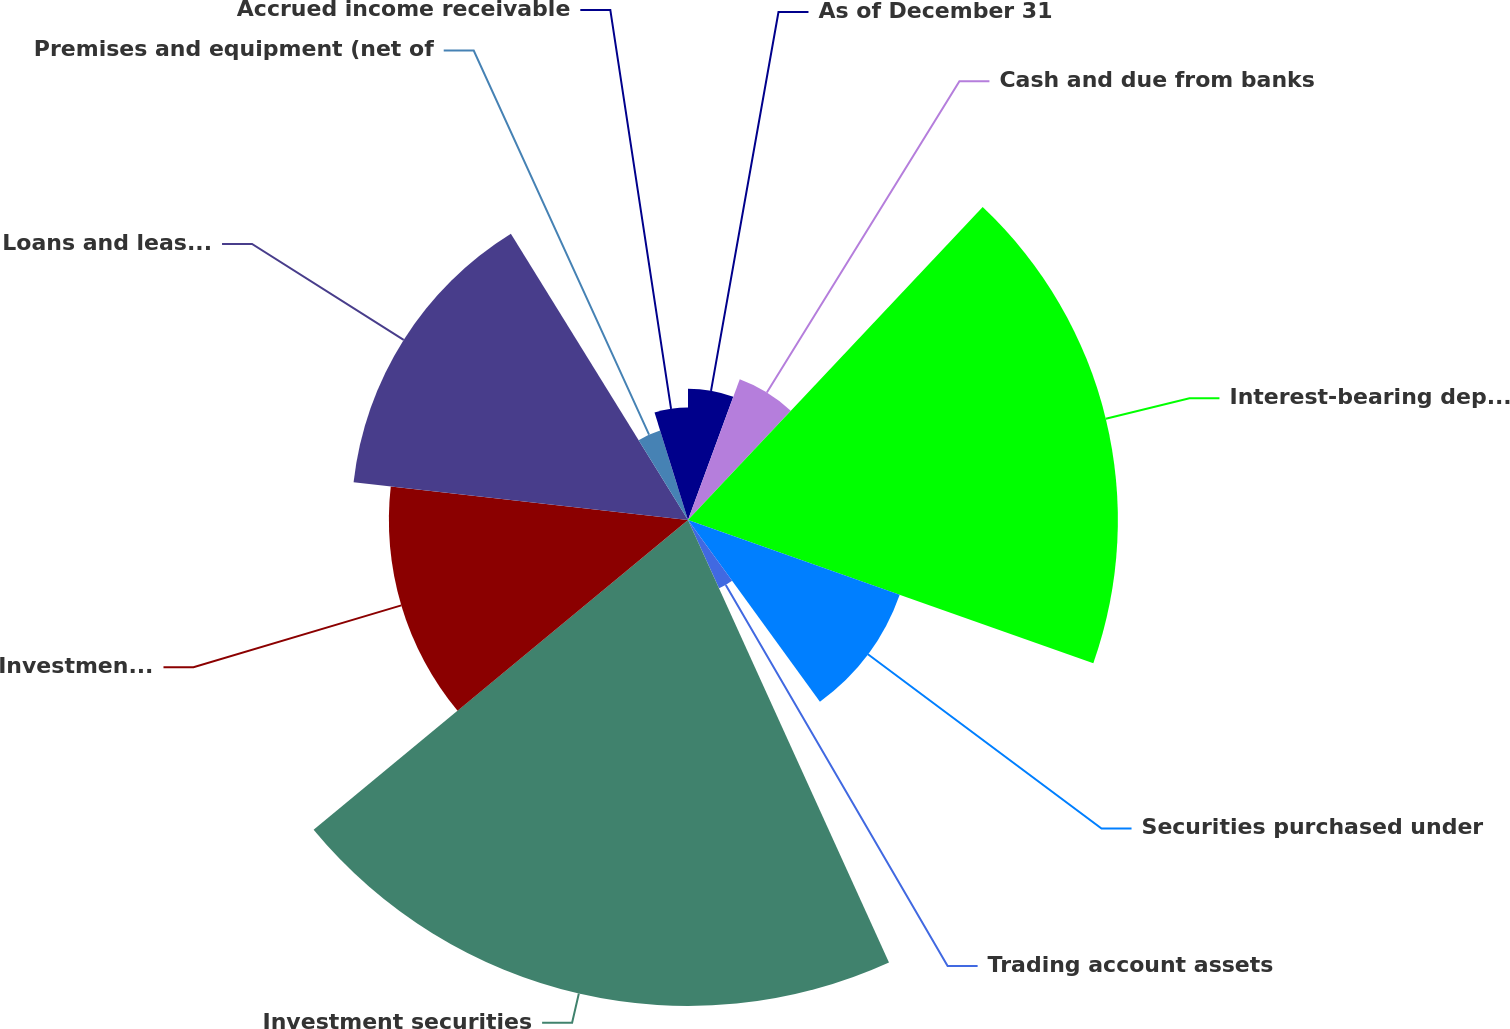Convert chart. <chart><loc_0><loc_0><loc_500><loc_500><pie_chart><fcel>As of December 31<fcel>Cash and due from banks<fcel>Interest-bearing deposits with<fcel>Securities purchased under<fcel>Trading account assets<fcel>Investment securities<fcel>Investment securities held to<fcel>Loans and leases (less<fcel>Premises and equipment (net of<fcel>Accrued income receivable<nl><fcel>5.61%<fcel>6.41%<fcel>18.38%<fcel>9.6%<fcel>3.21%<fcel>20.78%<fcel>12.79%<fcel>14.39%<fcel>4.01%<fcel>4.81%<nl></chart> 